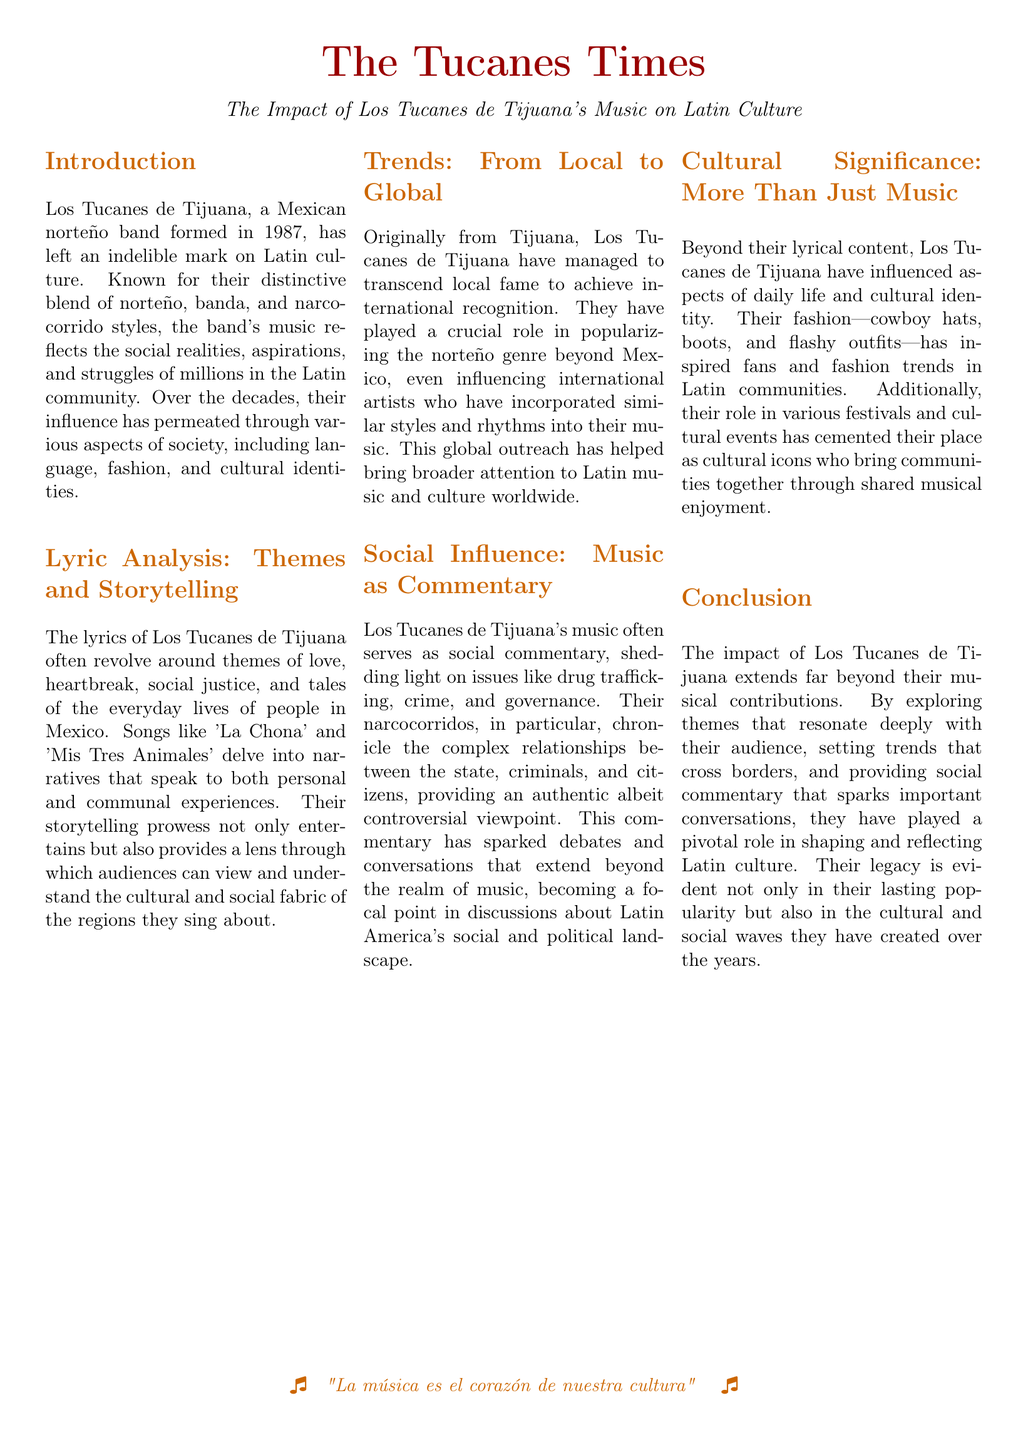What year was Los Tucanes de Tijuana formed? The document states that Los Tucanes de Tijuana was formed in 1987.
Answer: 1987 What music genres does Los Tucanes de Tijuana blend? The document mentions that they blend norteño, banda, and narcocorrido styles.
Answer: norteño, banda, and narcocorrido Name a song mentioned in the document that reflects everyday lives. The song 'La Chona' is mentioned as an example that delves into narratives of everyday lives.
Answer: La Chona What role have Los Tucanes de Tijuana played in terms of music? The document states that they have played a crucial role in popularizing the norteño genre beyond Mexico.
Answer: popularizing the norteño genre What social issues do Los Tucanes de Tijuana’s narcocorridos address? The document indicates that their narcocorridos chronicle issues like drug trafficking, crime, and governance.
Answer: drug trafficking, crime, and governance How have Los Tucanes de Tijuana influenced fashion? The document notes that their fashion includes cowboy hats, boots, and flashy outfits, inspiring fans and trends.
Answer: cowboy hats, boots, and flashy outfits What is the significance of their music according to the document? The document emphasizes that their music provides social commentary and sparks important conversations.
Answer: social commentary and important conversations What is the title of the publication? The publication is titled "The Tucanes Times."
Answer: The Tucanes Times 